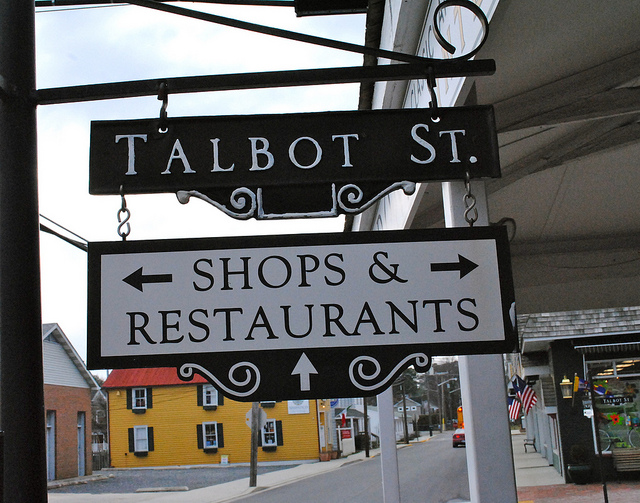What can I expect to find on Talbot St. in terms of shops and restaurants? Based on the street sign, Talbot St. likely offers a variety of shops and dining options. You might find boutiques, local artisan shops, and a range of restaurants offering different cuisines that reflect the local culture and taste. 